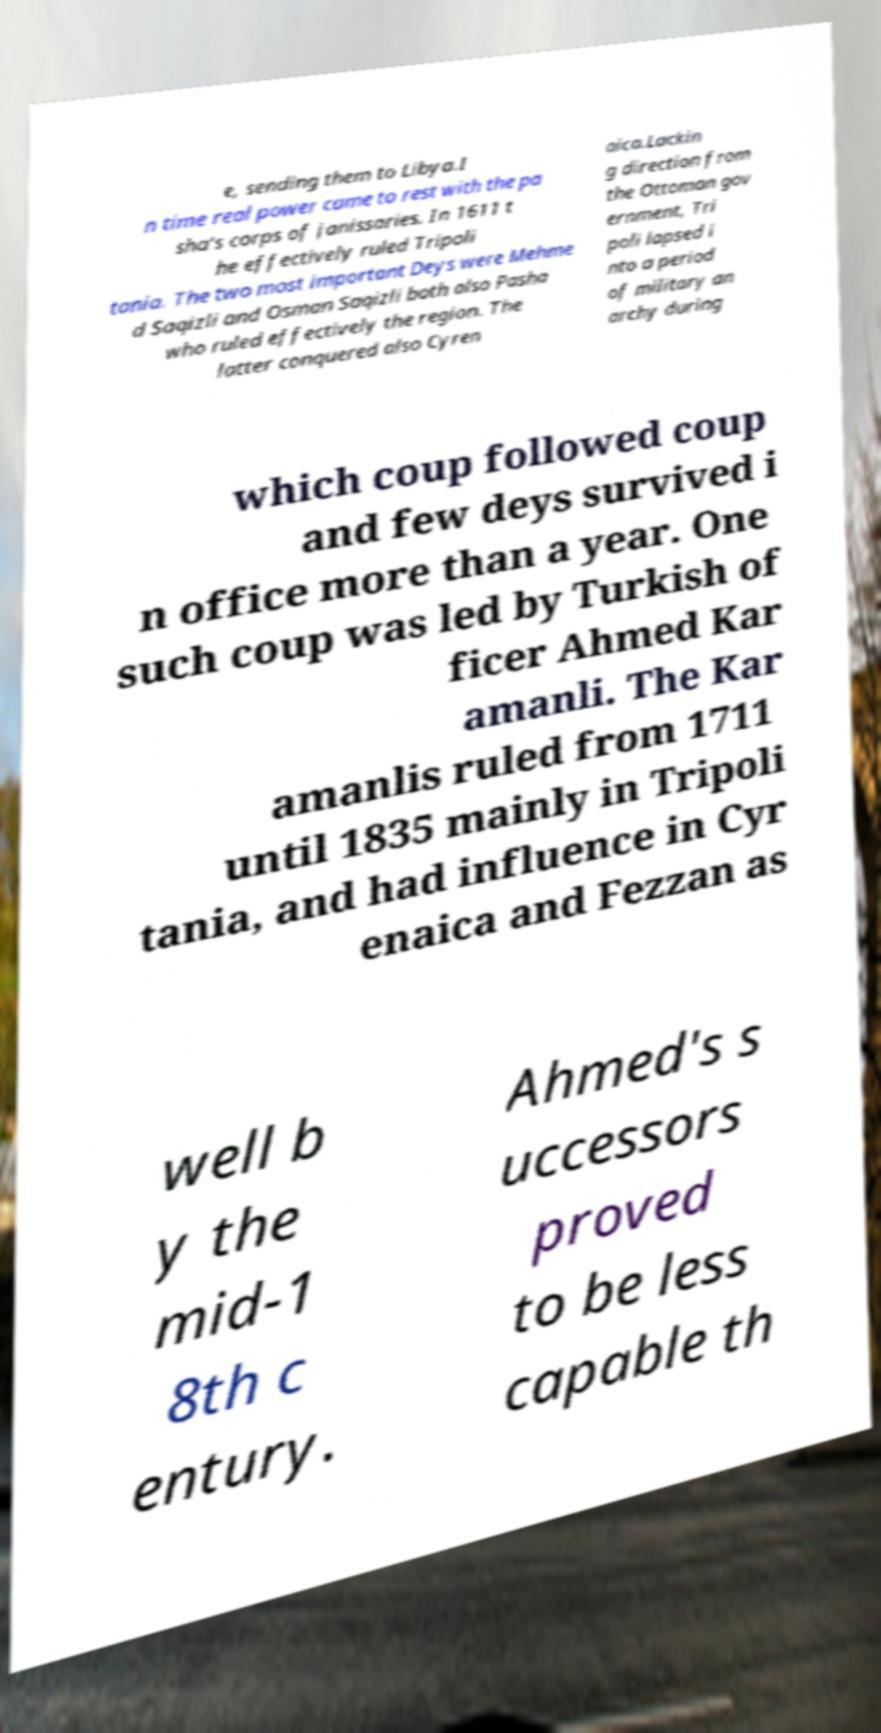There's text embedded in this image that I need extracted. Can you transcribe it verbatim? e, sending them to Libya.I n time real power came to rest with the pa sha's corps of janissaries. In 1611 t he effectively ruled Tripoli tania. The two most important Deys were Mehme d Saqizli and Osman Saqizli both also Pasha who ruled effectively the region. The latter conquered also Cyren aica.Lackin g direction from the Ottoman gov ernment, Tri poli lapsed i nto a period of military an archy during which coup followed coup and few deys survived i n office more than a year. One such coup was led by Turkish of ficer Ahmed Kar amanli. The Kar amanlis ruled from 1711 until 1835 mainly in Tripoli tania, and had influence in Cyr enaica and Fezzan as well b y the mid-1 8th c entury. Ahmed's s uccessors proved to be less capable th 